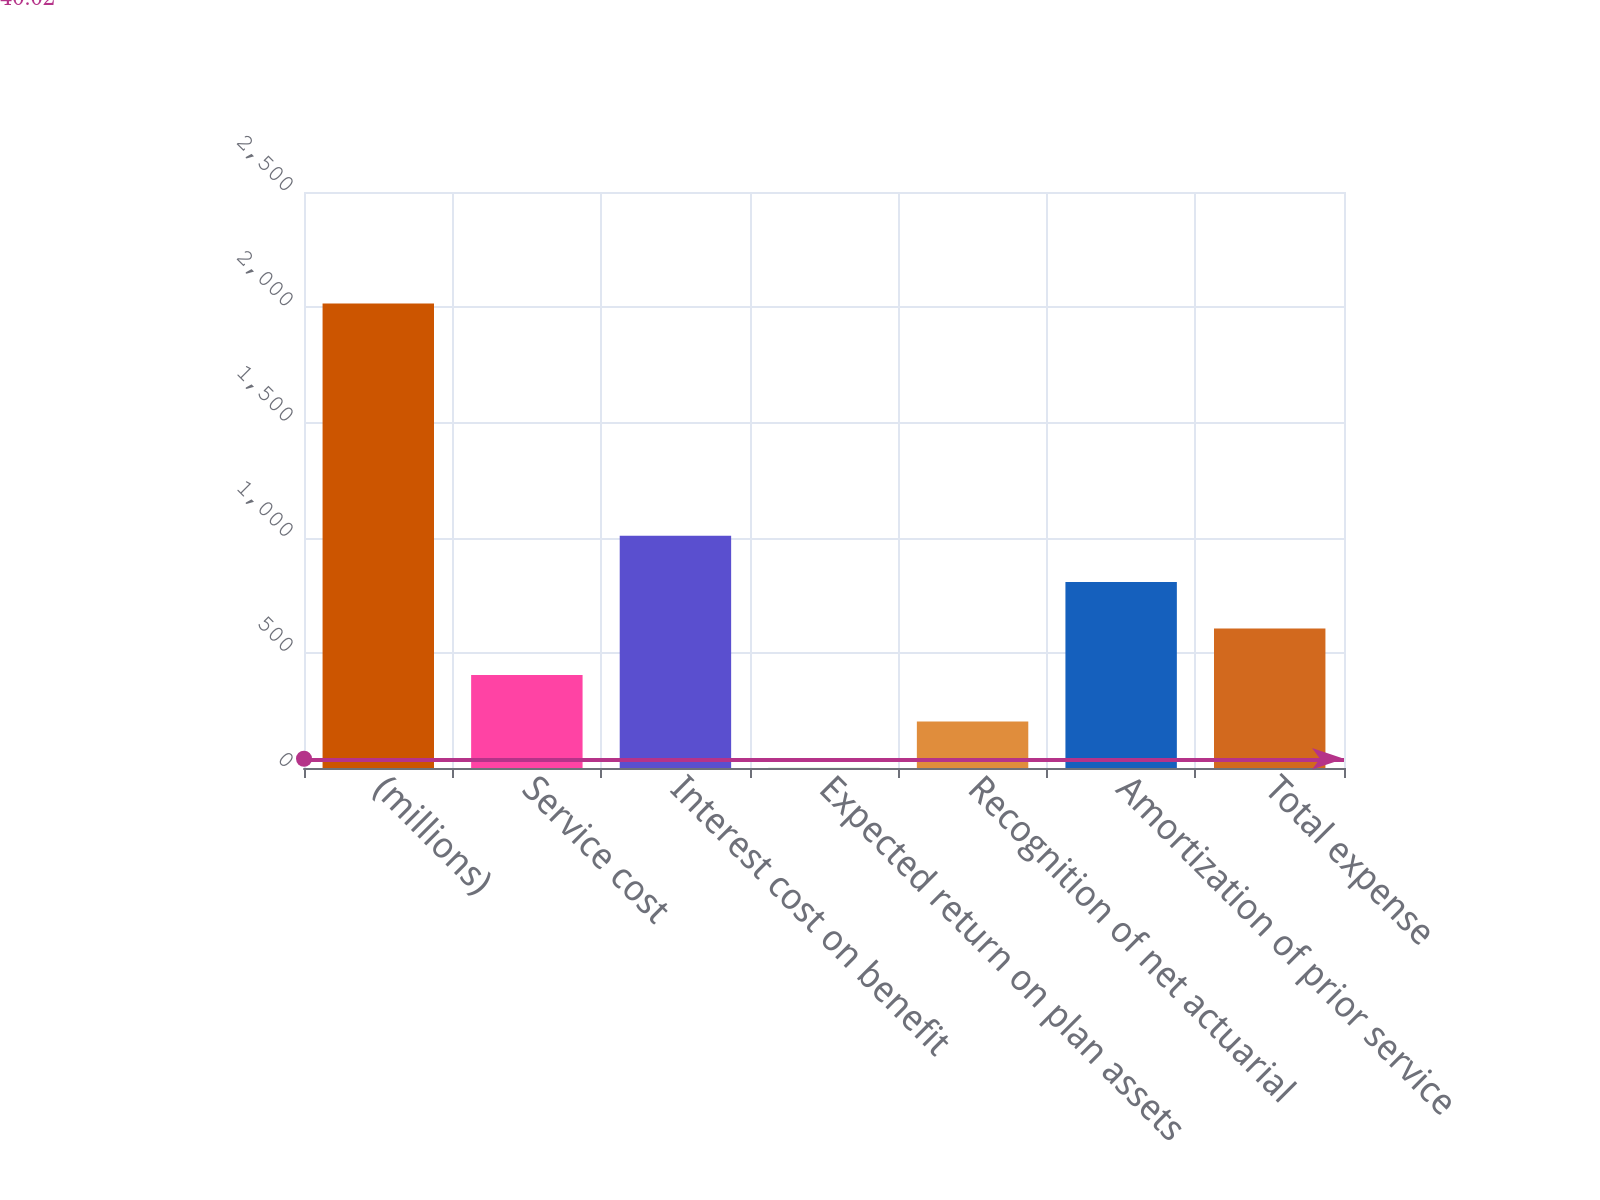Convert chart to OTSL. <chart><loc_0><loc_0><loc_500><loc_500><bar_chart><fcel>(millions)<fcel>Service cost<fcel>Interest cost on benefit<fcel>Expected return on plan assets<fcel>Recognition of net actuarial<fcel>Amortization of prior service<fcel>Total expense<nl><fcel>2016<fcel>403.76<fcel>1008.35<fcel>0.7<fcel>202.23<fcel>806.82<fcel>605.29<nl></chart> 